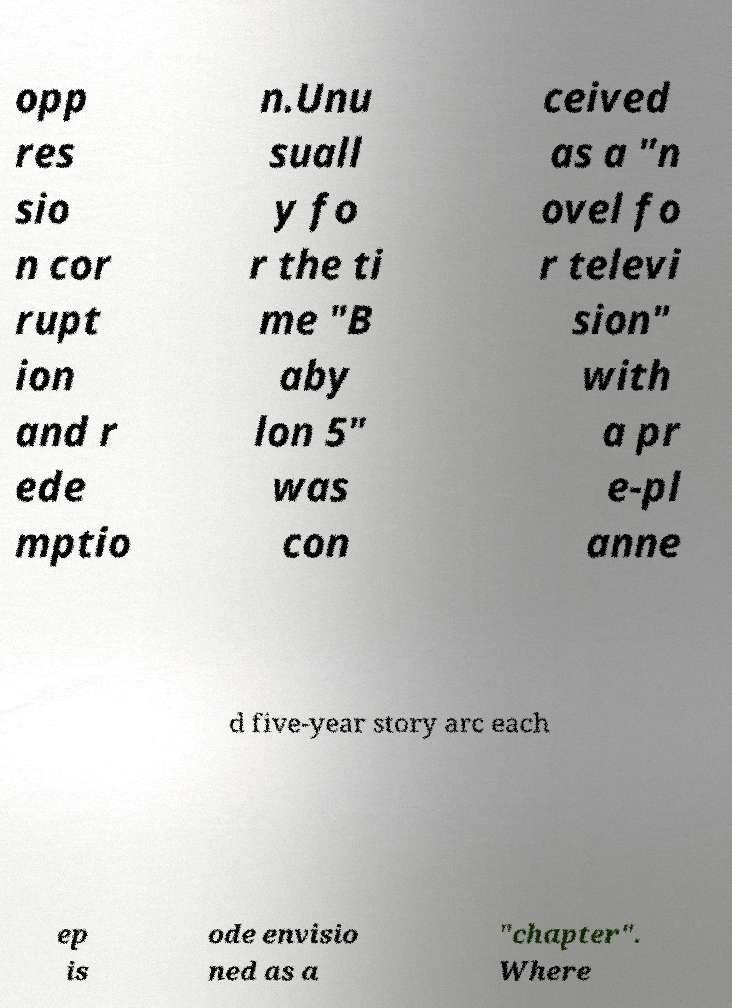What messages or text are displayed in this image? I need them in a readable, typed format. opp res sio n cor rupt ion and r ede mptio n.Unu suall y fo r the ti me "B aby lon 5" was con ceived as a "n ovel fo r televi sion" with a pr e-pl anne d five-year story arc each ep is ode envisio ned as a "chapter". Where 